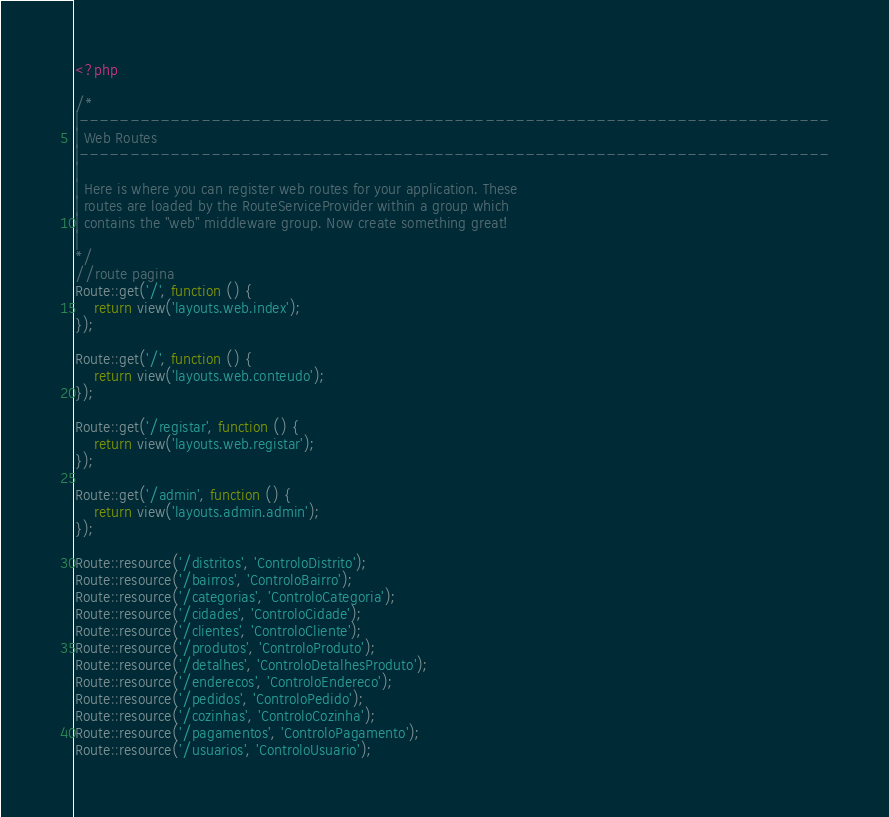Convert code to text. <code><loc_0><loc_0><loc_500><loc_500><_PHP_><?php

/*
|--------------------------------------------------------------------------
| Web Routes
|--------------------------------------------------------------------------
|
| Here is where you can register web routes for your application. These
| routes are loaded by the RouteServiceProvider within a group which
| contains the "web" middleware group. Now create something great!
|
*/
//route pagina
Route::get('/', function () {
    return view('layouts.web.index');
});

Route::get('/', function () {
    return view('layouts.web.conteudo');
});

Route::get('/registar', function () {
    return view('layouts.web.registar');
});

Route::get('/admin', function () {
    return view('layouts.admin.admin');
});

Route::resource('/distritos', 'ControloDistrito');
Route::resource('/bairros', 'ControloBairro');
Route::resource('/categorias', 'ControloCategoria');
Route::resource('/cidades', 'ControloCidade');
Route::resource('/clientes', 'ControloCliente');
Route::resource('/produtos', 'ControloProduto');
Route::resource('/detalhes', 'ControloDetalhesProduto');
Route::resource('/enderecos', 'ControloEndereco');
Route::resource('/pedidos', 'ControloPedido');
Route::resource('/cozinhas', 'ControloCozinha');
Route::resource('/pagamentos', 'ControloPagamento');
Route::resource('/usuarios', 'ControloUsuario');</code> 